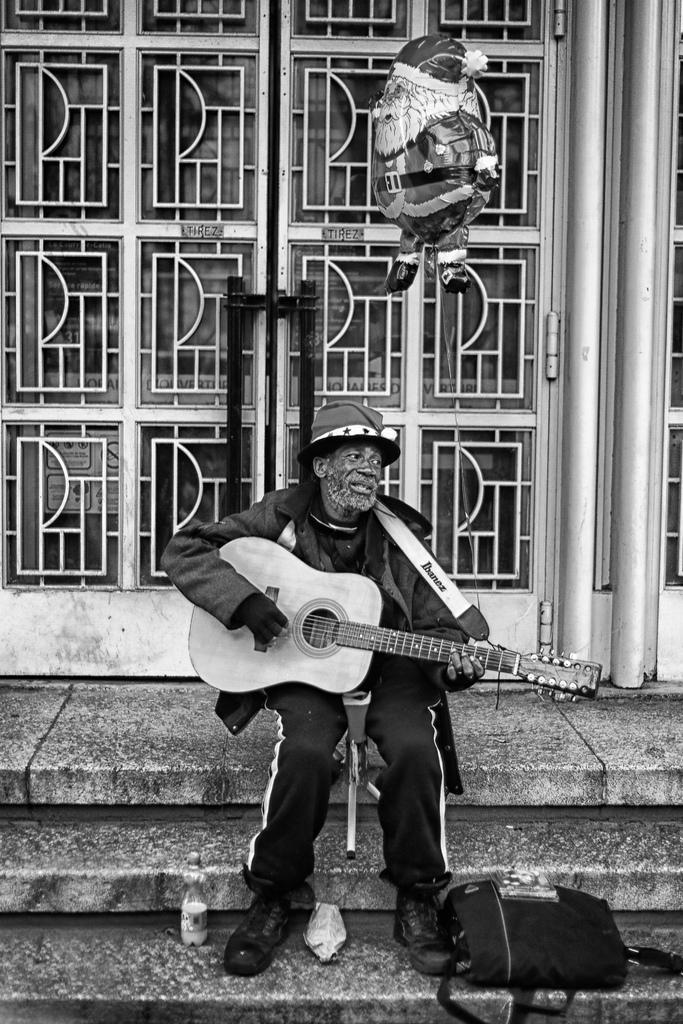Could you give a brief overview of what you see in this image? In this picture we can see a man who is sitting on the floor. And he is playing guitar. This is the bag and there is a door on the background. 